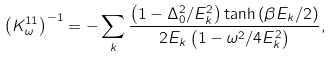Convert formula to latex. <formula><loc_0><loc_0><loc_500><loc_500>\left ( K ^ { 1 1 } _ { \omega } \right ) ^ { - 1 } = - \sum _ { k } \frac { \left ( 1 - \Delta _ { 0 } ^ { 2 } / E _ { k } ^ { 2 } \right ) \tanh { \left ( \beta E _ { k } / 2 \right ) } } { 2 E _ { k } \left ( 1 - \omega ^ { 2 } / 4 E ^ { 2 } _ { k } \right ) } ,</formula> 